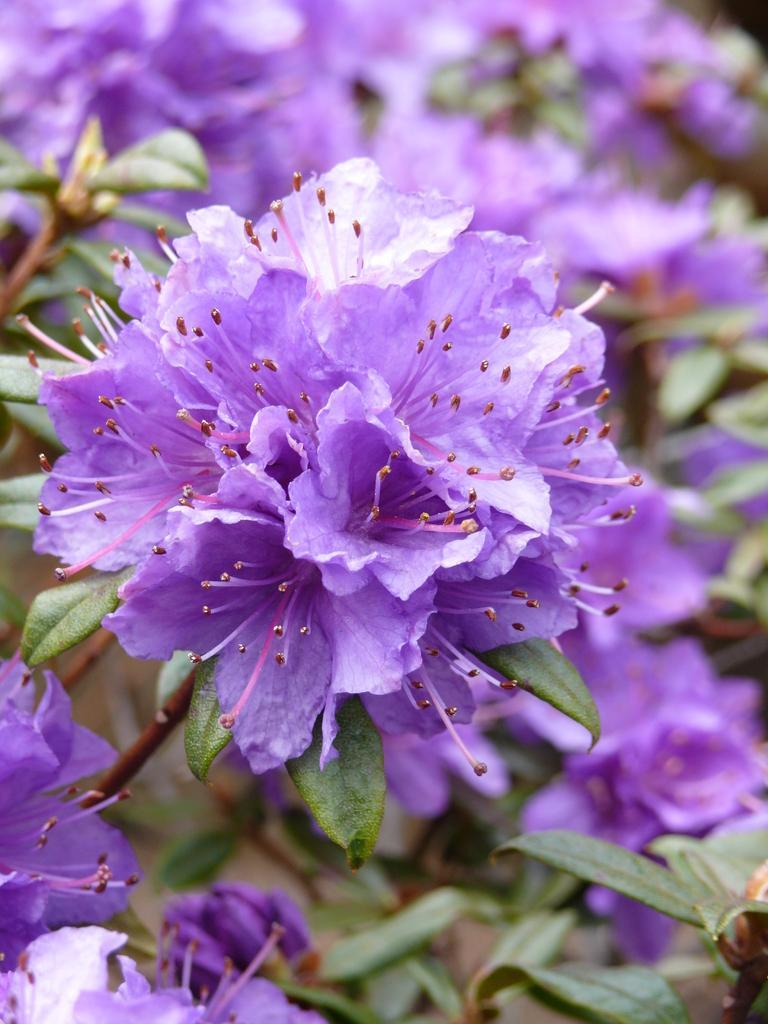Describe this image in one or two sentences. In this picture there is a flower in the center of the image and there are other flowers and leaves in the background area of the image. 